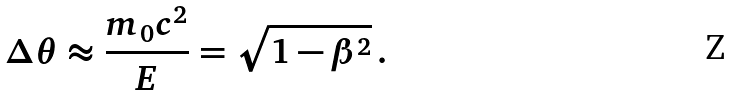<formula> <loc_0><loc_0><loc_500><loc_500>\Delta \theta \approx \frac { m _ { 0 } c ^ { 2 } } { E } = \sqrt { 1 - \beta ^ { 2 } } \, .</formula> 